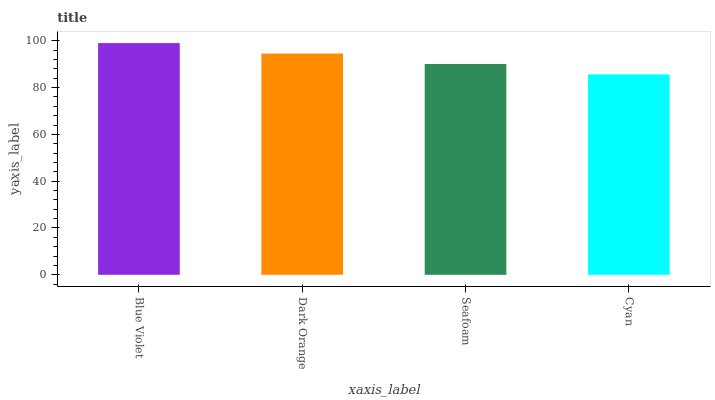Is Dark Orange the minimum?
Answer yes or no. No. Is Dark Orange the maximum?
Answer yes or no. No. Is Blue Violet greater than Dark Orange?
Answer yes or no. Yes. Is Dark Orange less than Blue Violet?
Answer yes or no. Yes. Is Dark Orange greater than Blue Violet?
Answer yes or no. No. Is Blue Violet less than Dark Orange?
Answer yes or no. No. Is Dark Orange the high median?
Answer yes or no. Yes. Is Seafoam the low median?
Answer yes or no. Yes. Is Seafoam the high median?
Answer yes or no. No. Is Dark Orange the low median?
Answer yes or no. No. 